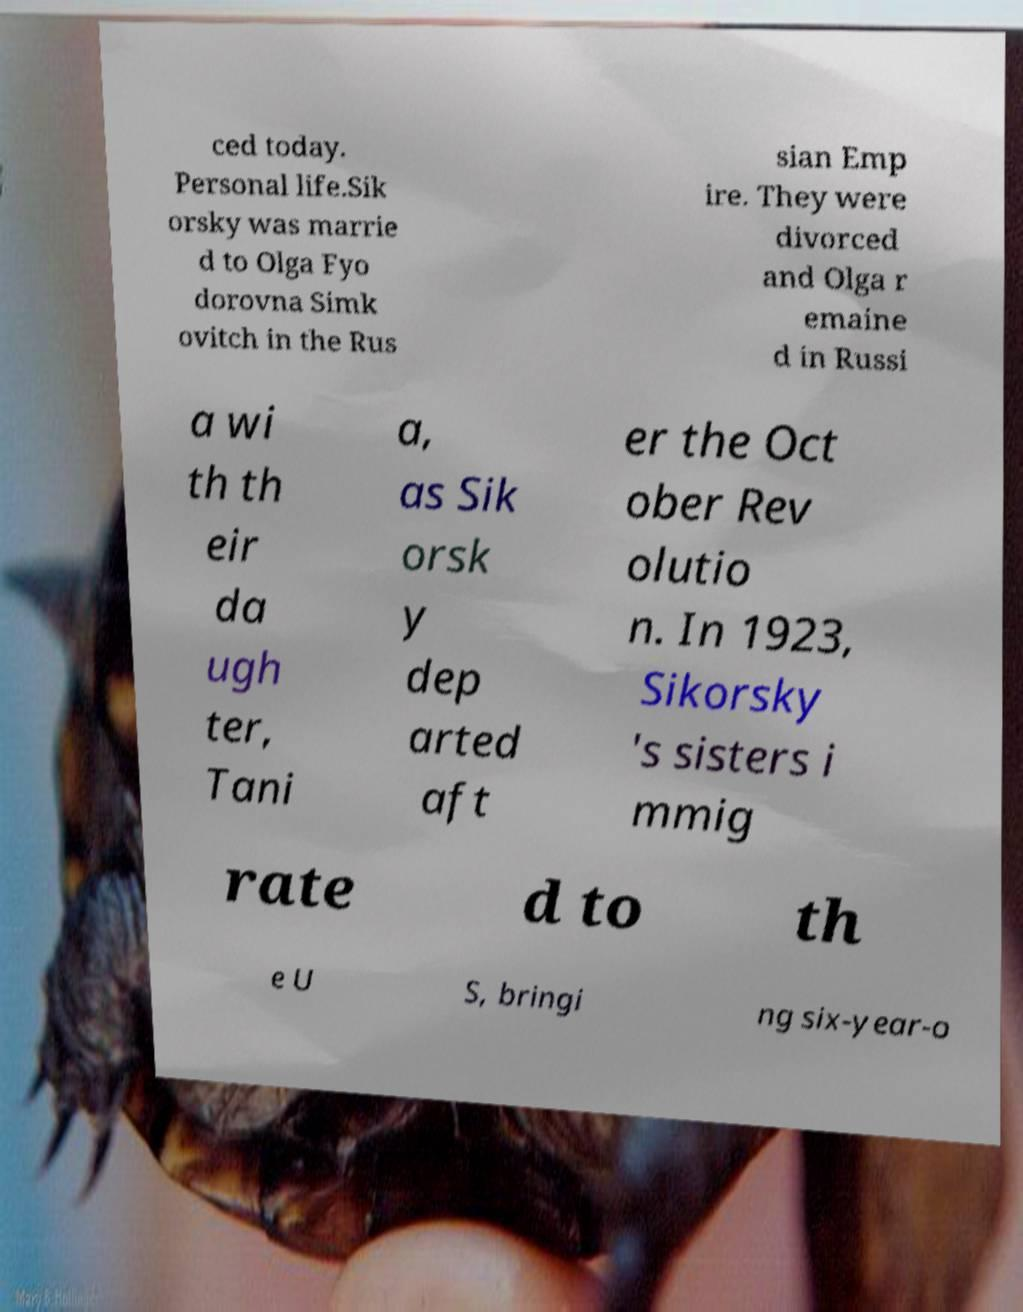Could you extract and type out the text from this image? ced today. Personal life.Sik orsky was marrie d to Olga Fyo dorovna Simk ovitch in the Rus sian Emp ire. They were divorced and Olga r emaine d in Russi a wi th th eir da ugh ter, Tani a, as Sik orsk y dep arted aft er the Oct ober Rev olutio n. In 1923, Sikorsky 's sisters i mmig rate d to th e U S, bringi ng six-year-o 